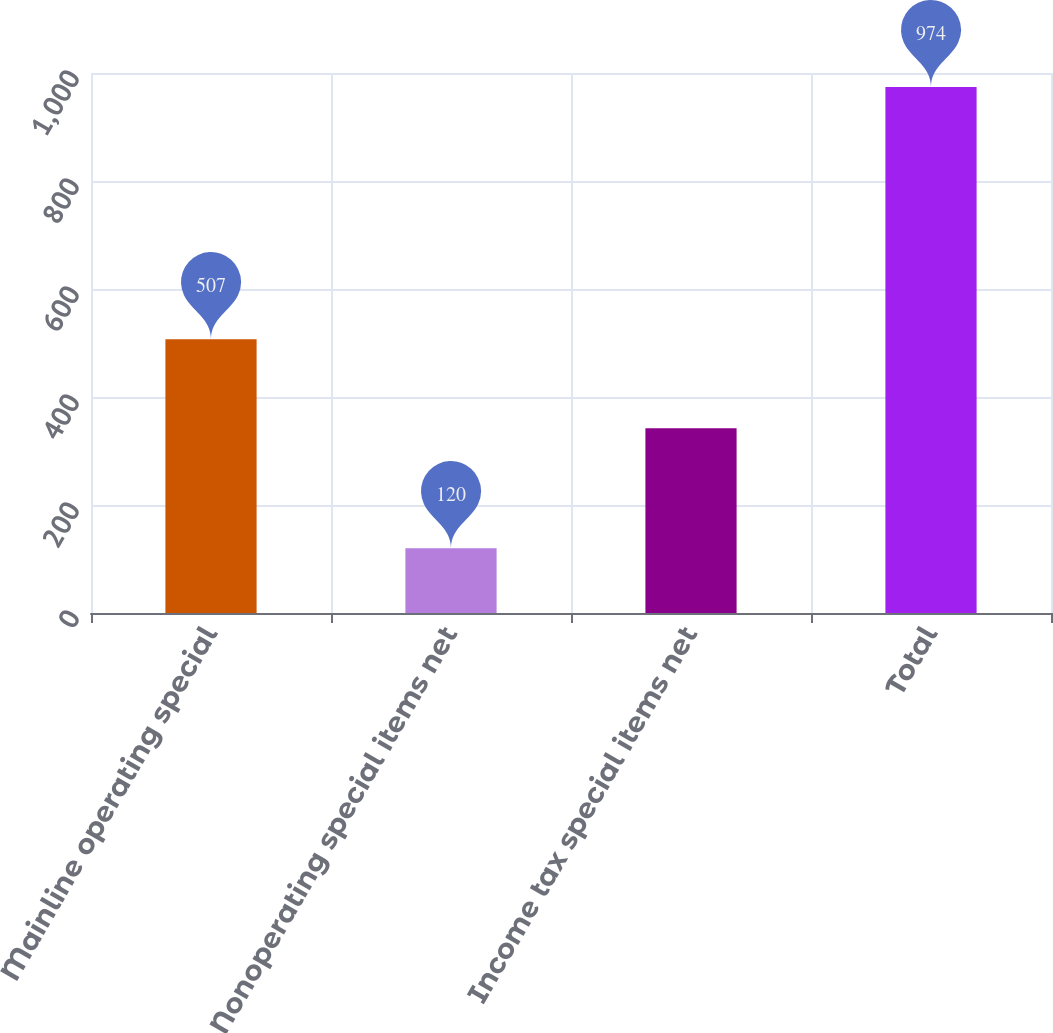Convert chart to OTSL. <chart><loc_0><loc_0><loc_500><loc_500><bar_chart><fcel>Mainline operating special<fcel>Nonoperating special items net<fcel>Income tax special items net<fcel>Total<nl><fcel>507<fcel>120<fcel>342<fcel>974<nl></chart> 